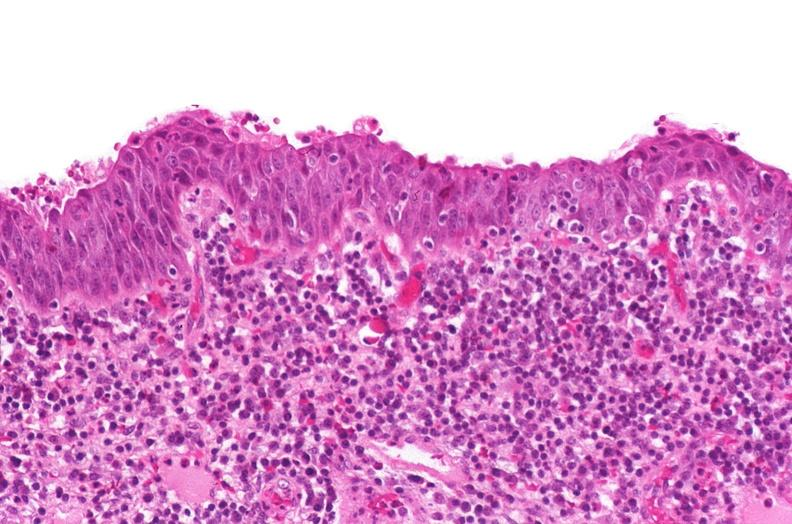s normal proximal tubule cell present?
Answer the question using a single word or phrase. No 